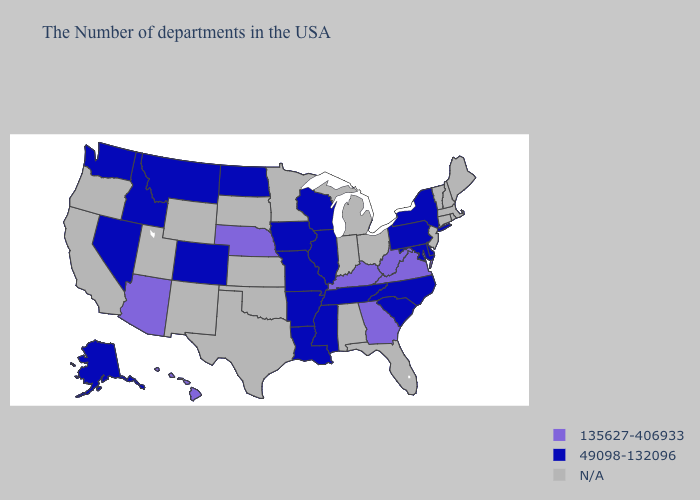Name the states that have a value in the range 135627-406933?
Concise answer only. Virginia, West Virginia, Georgia, Kentucky, Nebraska, Arizona, Hawaii. What is the highest value in the MidWest ?
Give a very brief answer. 135627-406933. What is the highest value in states that border Illinois?
Quick response, please. 135627-406933. What is the lowest value in the MidWest?
Quick response, please. 49098-132096. Does the map have missing data?
Short answer required. Yes. What is the value of Rhode Island?
Short answer required. N/A. What is the value of New Jersey?
Be succinct. N/A. What is the value of Rhode Island?
Write a very short answer. N/A. What is the lowest value in the Northeast?
Answer briefly. 49098-132096. Name the states that have a value in the range N/A?
Concise answer only. Maine, Massachusetts, Rhode Island, New Hampshire, Vermont, Connecticut, New Jersey, Ohio, Florida, Michigan, Indiana, Alabama, Minnesota, Kansas, Oklahoma, Texas, South Dakota, Wyoming, New Mexico, Utah, California, Oregon. Is the legend a continuous bar?
Concise answer only. No. Name the states that have a value in the range 49098-132096?
Short answer required. New York, Delaware, Maryland, Pennsylvania, North Carolina, South Carolina, Tennessee, Wisconsin, Illinois, Mississippi, Louisiana, Missouri, Arkansas, Iowa, North Dakota, Colorado, Montana, Idaho, Nevada, Washington, Alaska. What is the highest value in the USA?
Give a very brief answer. 135627-406933. 